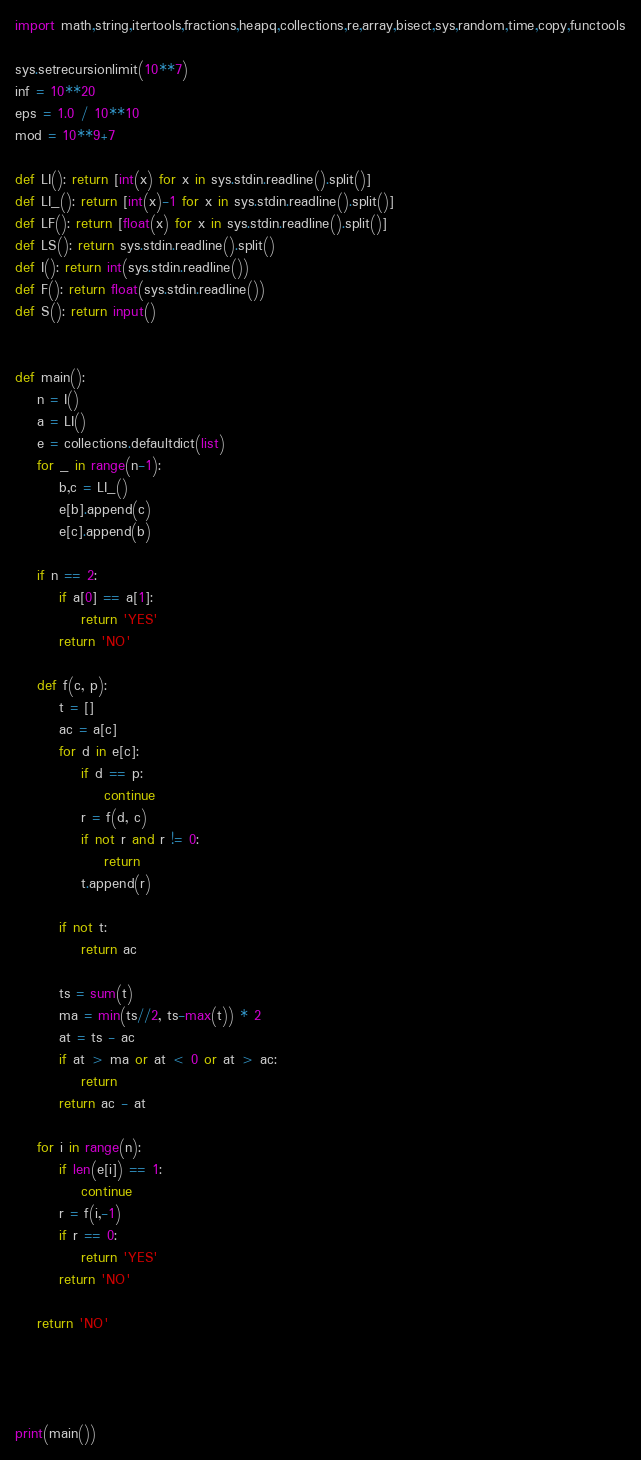Convert code to text. <code><loc_0><loc_0><loc_500><loc_500><_Python_>import math,string,itertools,fractions,heapq,collections,re,array,bisect,sys,random,time,copy,functools

sys.setrecursionlimit(10**7)
inf = 10**20
eps = 1.0 / 10**10
mod = 10**9+7

def LI(): return [int(x) for x in sys.stdin.readline().split()]
def LI_(): return [int(x)-1 for x in sys.stdin.readline().split()]
def LF(): return [float(x) for x in sys.stdin.readline().split()]
def LS(): return sys.stdin.readline().split()
def I(): return int(sys.stdin.readline())
def F(): return float(sys.stdin.readline())
def S(): return input()


def main():
    n = I()
    a = LI()
    e = collections.defaultdict(list)
    for _ in range(n-1):
        b,c = LI_()
        e[b].append(c)
        e[c].append(b)

    if n == 2:
        if a[0] == a[1]:
            return 'YES'
        return 'NO'

    def f(c, p):
        t = []
        ac = a[c]
        for d in e[c]:
            if d == p:
                continue
            r = f(d, c)
            if not r and r != 0:
                return
            t.append(r)

        if not t:
            return ac

        ts = sum(t)
        ma = min(ts//2, ts-max(t)) * 2
        at = ts - ac
        if at > ma or at < 0 or at > ac:
            return
        return ac - at

    for i in range(n):
        if len(e[i]) == 1:
            continue
        r = f(i,-1)
        if r == 0:
            return 'YES'
        return 'NO'

    return 'NO'




print(main())




</code> 